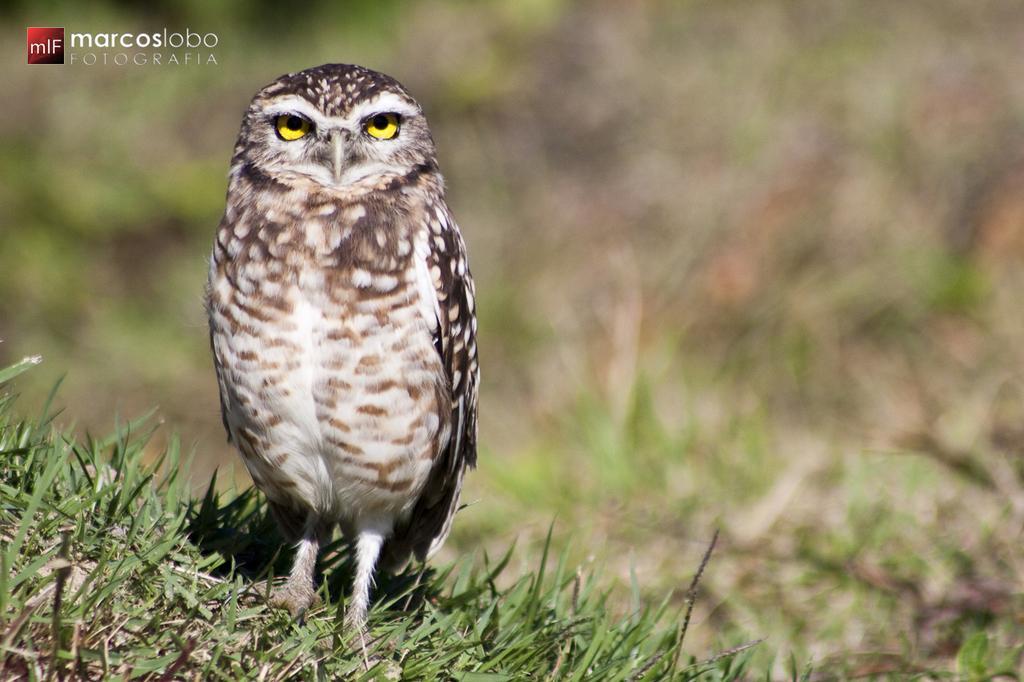Describe this image in one or two sentences. In this picture we can see a owl on the grass, on left top of the corner we can see a watermark. 